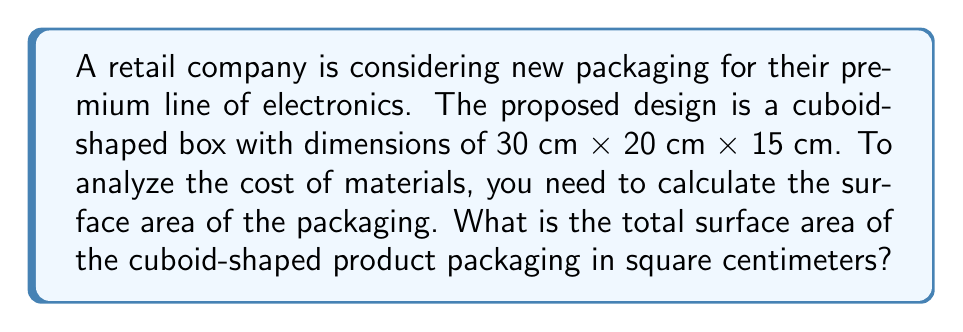Show me your answer to this math problem. Let's approach this step-by-step:

1) A cuboid has 6 faces: 2 identical faces for each dimension (length, width, height).

2) The dimensions given are:
   Length (l) = 30 cm
   Width (w) = 20 cm
   Height (h) = 15 cm

3) The surface area of a cuboid is given by the formula:
   $$SA = 2(lw + lh + wh)$$

4) Let's substitute the values:
   $$SA = 2[(30 \times 20) + (30 \times 15) + (20 \times 15)]$$

5) Calculate each part inside the parentheses:
   $$SA = 2[600 + 450 + 300]$$

6) Sum up inside the square brackets:
   $$SA = 2[1350]$$

7) Multiply:
   $$SA = 2700$$

Therefore, the total surface area of the cuboid-shaped product packaging is 2700 square centimeters.
Answer: 2700 cm² 